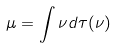Convert formula to latex. <formula><loc_0><loc_0><loc_500><loc_500>\mu = \int \nu d \tau ( \nu )</formula> 